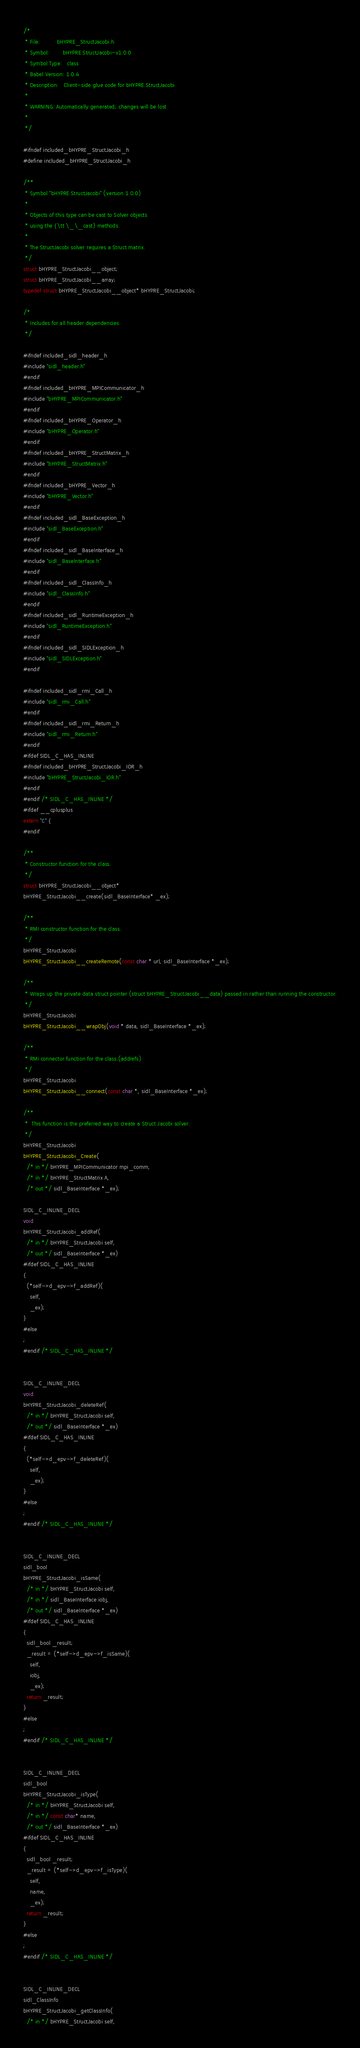<code> <loc_0><loc_0><loc_500><loc_500><_C_>/*
 * File:          bHYPRE_StructJacobi.h
 * Symbol:        bHYPRE.StructJacobi-v1.0.0
 * Symbol Type:   class
 * Babel Version: 1.0.4
 * Description:   Client-side glue code for bHYPRE.StructJacobi
 * 
 * WARNING: Automatically generated; changes will be lost
 * 
 */

#ifndef included_bHYPRE_StructJacobi_h
#define included_bHYPRE_StructJacobi_h

/**
 * Symbol "bHYPRE.StructJacobi" (version 1.0.0)
 * 
 * Objects of this type can be cast to Solver objects
 * using the {\tt \_\_cast} methods.
 * 
 * The StructJacobi solver requires a Struct matrix.
 */
struct bHYPRE_StructJacobi__object;
struct bHYPRE_StructJacobi__array;
typedef struct bHYPRE_StructJacobi__object* bHYPRE_StructJacobi;

/*
 * Includes for all header dependencies.
 */

#ifndef included_sidl_header_h
#include "sidl_header.h"
#endif
#ifndef included_bHYPRE_MPICommunicator_h
#include "bHYPRE_MPICommunicator.h"
#endif
#ifndef included_bHYPRE_Operator_h
#include "bHYPRE_Operator.h"
#endif
#ifndef included_bHYPRE_StructMatrix_h
#include "bHYPRE_StructMatrix.h"
#endif
#ifndef included_bHYPRE_Vector_h
#include "bHYPRE_Vector.h"
#endif
#ifndef included_sidl_BaseException_h
#include "sidl_BaseException.h"
#endif
#ifndef included_sidl_BaseInterface_h
#include "sidl_BaseInterface.h"
#endif
#ifndef included_sidl_ClassInfo_h
#include "sidl_ClassInfo.h"
#endif
#ifndef included_sidl_RuntimeException_h
#include "sidl_RuntimeException.h"
#endif
#ifndef included_sidl_SIDLException_h
#include "sidl_SIDLException.h"
#endif

#ifndef included_sidl_rmi_Call_h
#include "sidl_rmi_Call.h"
#endif
#ifndef included_sidl_rmi_Return_h
#include "sidl_rmi_Return.h"
#endif
#ifdef SIDL_C_HAS_INLINE
#ifndef included_bHYPRE_StructJacobi_IOR_h
#include "bHYPRE_StructJacobi_IOR.h"
#endif
#endif /* SIDL_C_HAS_INLINE */
#ifdef __cplusplus
extern "C" {
#endif

/**
 * Constructor function for the class.
 */
struct bHYPRE_StructJacobi__object*
bHYPRE_StructJacobi__create(sidl_BaseInterface* _ex);

/**
 * RMI constructor function for the class.
 */
bHYPRE_StructJacobi
bHYPRE_StructJacobi__createRemote(const char * url, sidl_BaseInterface *_ex);

/**
 * Wraps up the private data struct pointer (struct bHYPRE_StructJacobi__data) passed in rather than running the constructor.
 */
bHYPRE_StructJacobi
bHYPRE_StructJacobi__wrapObj(void * data, sidl_BaseInterface *_ex);

/**
 * RMI connector function for the class.(addrefs)
 */
bHYPRE_StructJacobi
bHYPRE_StructJacobi__connect(const char *, sidl_BaseInterface *_ex);

/**
 *  This function is the preferred way to create a Struct Jacobi solver. 
 */
bHYPRE_StructJacobi
bHYPRE_StructJacobi_Create(
  /* in */ bHYPRE_MPICommunicator mpi_comm,
  /* in */ bHYPRE_StructMatrix A,
  /* out */ sidl_BaseInterface *_ex);

SIDL_C_INLINE_DECL
void
bHYPRE_StructJacobi_addRef(
  /* in */ bHYPRE_StructJacobi self,
  /* out */ sidl_BaseInterface *_ex)
#ifdef SIDL_C_HAS_INLINE
{
  (*self->d_epv->f_addRef)(
    self,
    _ex);
}
#else
;
#endif /* SIDL_C_HAS_INLINE */


SIDL_C_INLINE_DECL
void
bHYPRE_StructJacobi_deleteRef(
  /* in */ bHYPRE_StructJacobi self,
  /* out */ sidl_BaseInterface *_ex)
#ifdef SIDL_C_HAS_INLINE
{
  (*self->d_epv->f_deleteRef)(
    self,
    _ex);
}
#else
;
#endif /* SIDL_C_HAS_INLINE */


SIDL_C_INLINE_DECL
sidl_bool
bHYPRE_StructJacobi_isSame(
  /* in */ bHYPRE_StructJacobi self,
  /* in */ sidl_BaseInterface iobj,
  /* out */ sidl_BaseInterface *_ex)
#ifdef SIDL_C_HAS_INLINE
{
  sidl_bool _result;
  _result = (*self->d_epv->f_isSame)(
    self,
    iobj,
    _ex);
  return _result;
}
#else
;
#endif /* SIDL_C_HAS_INLINE */


SIDL_C_INLINE_DECL
sidl_bool
bHYPRE_StructJacobi_isType(
  /* in */ bHYPRE_StructJacobi self,
  /* in */ const char* name,
  /* out */ sidl_BaseInterface *_ex)
#ifdef SIDL_C_HAS_INLINE
{
  sidl_bool _result;
  _result = (*self->d_epv->f_isType)(
    self,
    name,
    _ex);
  return _result;
}
#else
;
#endif /* SIDL_C_HAS_INLINE */


SIDL_C_INLINE_DECL
sidl_ClassInfo
bHYPRE_StructJacobi_getClassInfo(
  /* in */ bHYPRE_StructJacobi self,</code> 